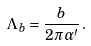Convert formula to latex. <formula><loc_0><loc_0><loc_500><loc_500>\Lambda _ { b } = \frac { b } { 2 \pi \alpha ^ { \prime } } \, .</formula> 